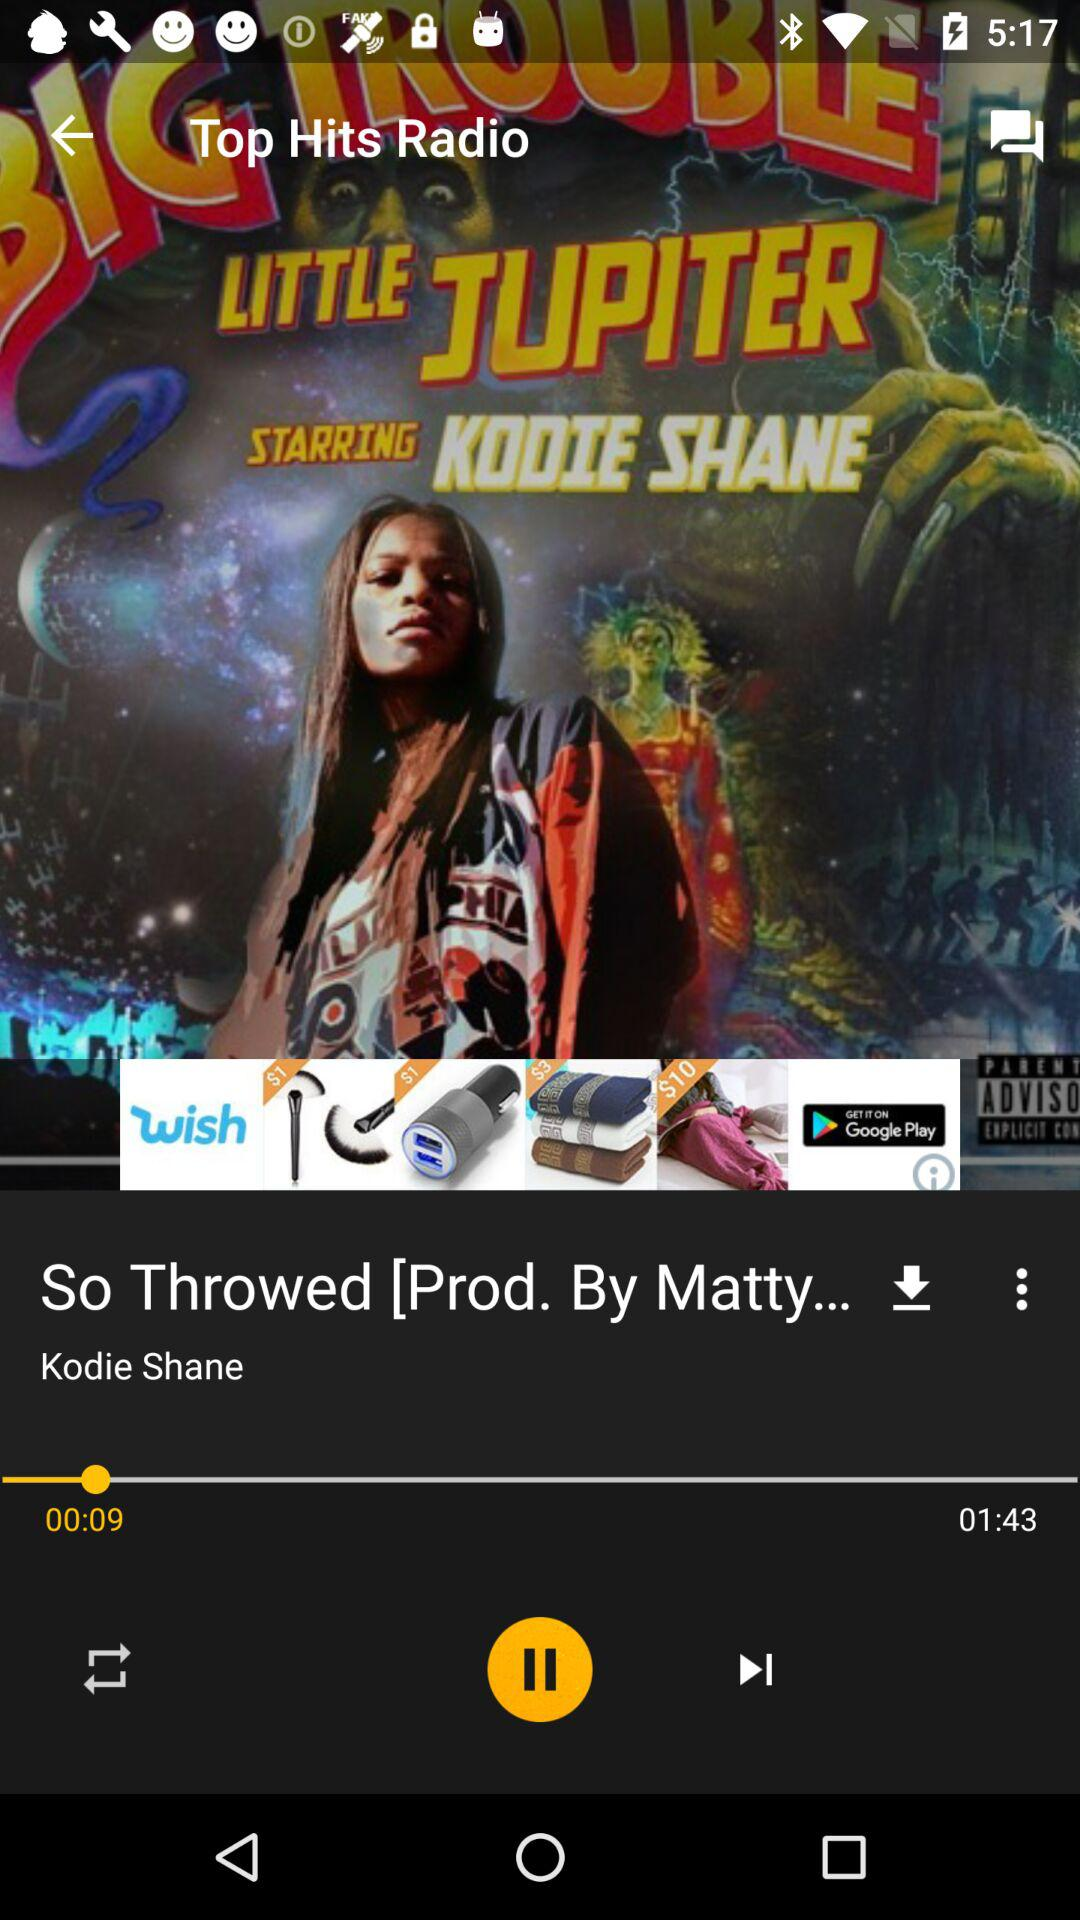What is the duration of the audio that is currently playing? The duration is 1 minute and 43 seconds. 